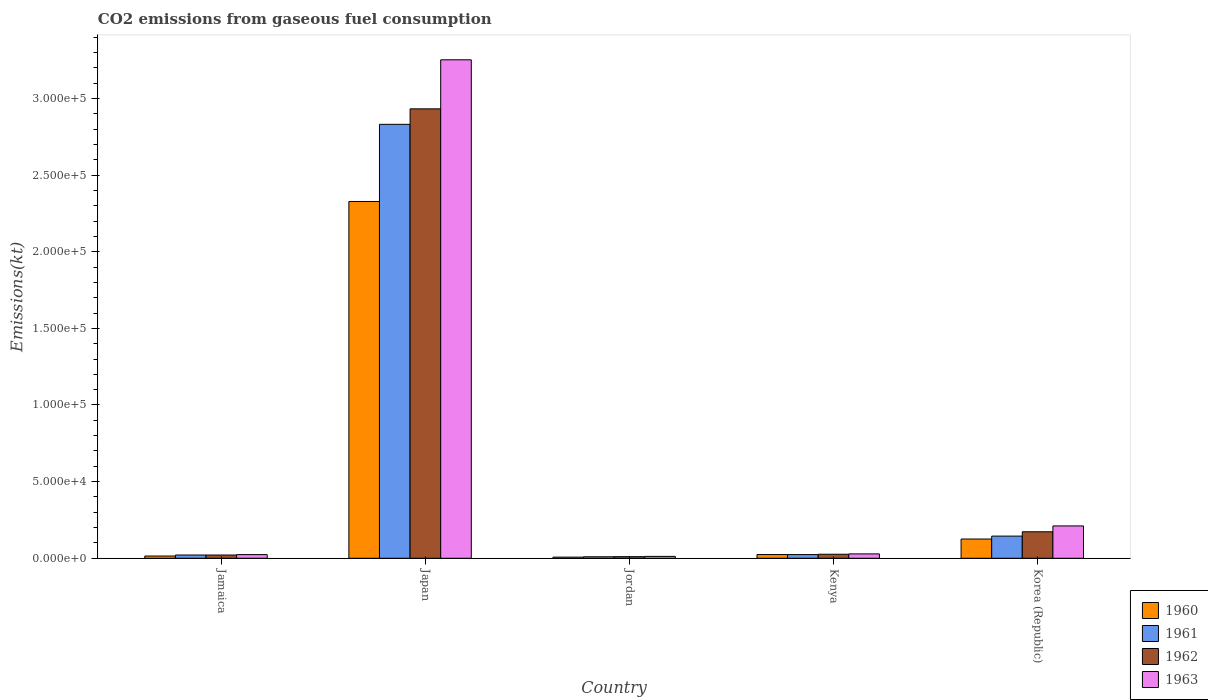Are the number of bars on each tick of the X-axis equal?
Your answer should be very brief. Yes. How many bars are there on the 5th tick from the left?
Give a very brief answer. 4. In how many cases, is the number of bars for a given country not equal to the number of legend labels?
Your response must be concise. 0. What is the amount of CO2 emitted in 1963 in Kenya?
Offer a very short reply. 2856.59. Across all countries, what is the maximum amount of CO2 emitted in 1963?
Provide a succinct answer. 3.25e+05. Across all countries, what is the minimum amount of CO2 emitted in 1963?
Your answer should be very brief. 1221.11. In which country was the amount of CO2 emitted in 1960 maximum?
Keep it short and to the point. Japan. In which country was the amount of CO2 emitted in 1963 minimum?
Your response must be concise. Jordan. What is the total amount of CO2 emitted in 1960 in the graph?
Offer a terse response. 2.50e+05. What is the difference between the amount of CO2 emitted in 1962 in Jamaica and that in Japan?
Offer a very short reply. -2.91e+05. What is the difference between the amount of CO2 emitted in 1961 in Jamaica and the amount of CO2 emitted in 1963 in Kenya?
Provide a succinct answer. -726.07. What is the average amount of CO2 emitted in 1962 per country?
Ensure brevity in your answer.  6.33e+04. What is the difference between the amount of CO2 emitted of/in 1961 and amount of CO2 emitted of/in 1962 in Jordan?
Make the answer very short. -69.67. What is the ratio of the amount of CO2 emitted in 1960 in Jamaica to that in Kenya?
Give a very brief answer. 0.61. Is the difference between the amount of CO2 emitted in 1961 in Jamaica and Jordan greater than the difference between the amount of CO2 emitted in 1962 in Jamaica and Jordan?
Give a very brief answer. Yes. What is the difference between the highest and the second highest amount of CO2 emitted in 1960?
Provide a short and direct response. 1.01e+04. What is the difference between the highest and the lowest amount of CO2 emitted in 1960?
Your response must be concise. 2.32e+05. In how many countries, is the amount of CO2 emitted in 1963 greater than the average amount of CO2 emitted in 1963 taken over all countries?
Your answer should be compact. 1. What does the 2nd bar from the left in Kenya represents?
Offer a very short reply. 1961. How many countries are there in the graph?
Give a very brief answer. 5. What is the difference between two consecutive major ticks on the Y-axis?
Offer a terse response. 5.00e+04. Are the values on the major ticks of Y-axis written in scientific E-notation?
Ensure brevity in your answer.  Yes. Does the graph contain any zero values?
Offer a very short reply. No. Does the graph contain grids?
Make the answer very short. No. How many legend labels are there?
Provide a short and direct response. 4. What is the title of the graph?
Your response must be concise. CO2 emissions from gaseous fuel consumption. What is the label or title of the X-axis?
Give a very brief answer. Country. What is the label or title of the Y-axis?
Make the answer very short. Emissions(kt). What is the Emissions(kt) of 1960 in Jamaica?
Ensure brevity in your answer.  1470.47. What is the Emissions(kt) in 1961 in Jamaica?
Your answer should be very brief. 2130.53. What is the Emissions(kt) in 1962 in Jamaica?
Your response must be concise. 2119.53. What is the Emissions(kt) in 1963 in Jamaica?
Keep it short and to the point. 2398.22. What is the Emissions(kt) in 1960 in Japan?
Your answer should be compact. 2.33e+05. What is the Emissions(kt) in 1961 in Japan?
Offer a very short reply. 2.83e+05. What is the Emissions(kt) of 1962 in Japan?
Your answer should be very brief. 2.93e+05. What is the Emissions(kt) of 1963 in Japan?
Offer a terse response. 3.25e+05. What is the Emissions(kt) of 1960 in Jordan?
Your answer should be compact. 744.4. What is the Emissions(kt) in 1961 in Jordan?
Make the answer very short. 979.09. What is the Emissions(kt) of 1962 in Jordan?
Offer a very short reply. 1048.76. What is the Emissions(kt) of 1963 in Jordan?
Provide a short and direct response. 1221.11. What is the Emissions(kt) of 1960 in Kenya?
Ensure brevity in your answer.  2427.55. What is the Emissions(kt) in 1961 in Kenya?
Ensure brevity in your answer.  2401.89. What is the Emissions(kt) of 1962 in Kenya?
Provide a short and direct response. 2625.57. What is the Emissions(kt) in 1963 in Kenya?
Provide a succinct answer. 2856.59. What is the Emissions(kt) of 1960 in Korea (Republic)?
Offer a very short reply. 1.26e+04. What is the Emissions(kt) of 1961 in Korea (Republic)?
Your answer should be compact. 1.45e+04. What is the Emissions(kt) in 1962 in Korea (Republic)?
Ensure brevity in your answer.  1.73e+04. What is the Emissions(kt) of 1963 in Korea (Republic)?
Keep it short and to the point. 2.11e+04. Across all countries, what is the maximum Emissions(kt) in 1960?
Offer a terse response. 2.33e+05. Across all countries, what is the maximum Emissions(kt) in 1961?
Make the answer very short. 2.83e+05. Across all countries, what is the maximum Emissions(kt) of 1962?
Offer a very short reply. 2.93e+05. Across all countries, what is the maximum Emissions(kt) of 1963?
Your answer should be compact. 3.25e+05. Across all countries, what is the minimum Emissions(kt) in 1960?
Provide a succinct answer. 744.4. Across all countries, what is the minimum Emissions(kt) of 1961?
Your answer should be compact. 979.09. Across all countries, what is the minimum Emissions(kt) in 1962?
Provide a short and direct response. 1048.76. Across all countries, what is the minimum Emissions(kt) in 1963?
Offer a terse response. 1221.11. What is the total Emissions(kt) in 1960 in the graph?
Make the answer very short. 2.50e+05. What is the total Emissions(kt) in 1961 in the graph?
Your response must be concise. 3.03e+05. What is the total Emissions(kt) in 1962 in the graph?
Offer a terse response. 3.16e+05. What is the total Emissions(kt) in 1963 in the graph?
Provide a short and direct response. 3.53e+05. What is the difference between the Emissions(kt) of 1960 in Jamaica and that in Japan?
Provide a succinct answer. -2.31e+05. What is the difference between the Emissions(kt) of 1961 in Jamaica and that in Japan?
Offer a terse response. -2.81e+05. What is the difference between the Emissions(kt) in 1962 in Jamaica and that in Japan?
Ensure brevity in your answer.  -2.91e+05. What is the difference between the Emissions(kt) in 1963 in Jamaica and that in Japan?
Offer a terse response. -3.23e+05. What is the difference between the Emissions(kt) of 1960 in Jamaica and that in Jordan?
Make the answer very short. 726.07. What is the difference between the Emissions(kt) in 1961 in Jamaica and that in Jordan?
Your answer should be compact. 1151.44. What is the difference between the Emissions(kt) in 1962 in Jamaica and that in Jordan?
Give a very brief answer. 1070.76. What is the difference between the Emissions(kt) of 1963 in Jamaica and that in Jordan?
Your answer should be compact. 1177.11. What is the difference between the Emissions(kt) in 1960 in Jamaica and that in Kenya?
Ensure brevity in your answer.  -957.09. What is the difference between the Emissions(kt) in 1961 in Jamaica and that in Kenya?
Provide a succinct answer. -271.36. What is the difference between the Emissions(kt) of 1962 in Jamaica and that in Kenya?
Your answer should be very brief. -506.05. What is the difference between the Emissions(kt) of 1963 in Jamaica and that in Kenya?
Provide a short and direct response. -458.38. What is the difference between the Emissions(kt) in 1960 in Jamaica and that in Korea (Republic)?
Your answer should be very brief. -1.11e+04. What is the difference between the Emissions(kt) of 1961 in Jamaica and that in Korea (Republic)?
Keep it short and to the point. -1.23e+04. What is the difference between the Emissions(kt) of 1962 in Jamaica and that in Korea (Republic)?
Provide a short and direct response. -1.52e+04. What is the difference between the Emissions(kt) of 1963 in Jamaica and that in Korea (Republic)?
Make the answer very short. -1.87e+04. What is the difference between the Emissions(kt) in 1960 in Japan and that in Jordan?
Offer a very short reply. 2.32e+05. What is the difference between the Emissions(kt) of 1961 in Japan and that in Jordan?
Your answer should be compact. 2.82e+05. What is the difference between the Emissions(kt) of 1962 in Japan and that in Jordan?
Keep it short and to the point. 2.92e+05. What is the difference between the Emissions(kt) of 1963 in Japan and that in Jordan?
Your response must be concise. 3.24e+05. What is the difference between the Emissions(kt) in 1960 in Japan and that in Kenya?
Provide a short and direct response. 2.30e+05. What is the difference between the Emissions(kt) in 1961 in Japan and that in Kenya?
Your answer should be compact. 2.81e+05. What is the difference between the Emissions(kt) in 1962 in Japan and that in Kenya?
Your response must be concise. 2.91e+05. What is the difference between the Emissions(kt) of 1963 in Japan and that in Kenya?
Offer a very short reply. 3.22e+05. What is the difference between the Emissions(kt) in 1960 in Japan and that in Korea (Republic)?
Your response must be concise. 2.20e+05. What is the difference between the Emissions(kt) of 1961 in Japan and that in Korea (Republic)?
Make the answer very short. 2.69e+05. What is the difference between the Emissions(kt) in 1962 in Japan and that in Korea (Republic)?
Make the answer very short. 2.76e+05. What is the difference between the Emissions(kt) of 1963 in Japan and that in Korea (Republic)?
Your answer should be compact. 3.04e+05. What is the difference between the Emissions(kt) in 1960 in Jordan and that in Kenya?
Give a very brief answer. -1683.15. What is the difference between the Emissions(kt) in 1961 in Jordan and that in Kenya?
Give a very brief answer. -1422.8. What is the difference between the Emissions(kt) of 1962 in Jordan and that in Kenya?
Provide a short and direct response. -1576.81. What is the difference between the Emissions(kt) of 1963 in Jordan and that in Kenya?
Your answer should be compact. -1635.48. What is the difference between the Emissions(kt) of 1960 in Jordan and that in Korea (Republic)?
Your answer should be very brief. -1.18e+04. What is the difference between the Emissions(kt) of 1961 in Jordan and that in Korea (Republic)?
Your answer should be very brief. -1.35e+04. What is the difference between the Emissions(kt) in 1962 in Jordan and that in Korea (Republic)?
Your response must be concise. -1.62e+04. What is the difference between the Emissions(kt) of 1963 in Jordan and that in Korea (Republic)?
Your response must be concise. -1.99e+04. What is the difference between the Emissions(kt) of 1960 in Kenya and that in Korea (Republic)?
Offer a terse response. -1.01e+04. What is the difference between the Emissions(kt) of 1961 in Kenya and that in Korea (Republic)?
Ensure brevity in your answer.  -1.21e+04. What is the difference between the Emissions(kt) of 1962 in Kenya and that in Korea (Republic)?
Ensure brevity in your answer.  -1.47e+04. What is the difference between the Emissions(kt) in 1963 in Kenya and that in Korea (Republic)?
Give a very brief answer. -1.82e+04. What is the difference between the Emissions(kt) in 1960 in Jamaica and the Emissions(kt) in 1961 in Japan?
Your answer should be very brief. -2.82e+05. What is the difference between the Emissions(kt) in 1960 in Jamaica and the Emissions(kt) in 1962 in Japan?
Your response must be concise. -2.92e+05. What is the difference between the Emissions(kt) in 1960 in Jamaica and the Emissions(kt) in 1963 in Japan?
Provide a succinct answer. -3.24e+05. What is the difference between the Emissions(kt) of 1961 in Jamaica and the Emissions(kt) of 1962 in Japan?
Provide a short and direct response. -2.91e+05. What is the difference between the Emissions(kt) of 1961 in Jamaica and the Emissions(kt) of 1963 in Japan?
Ensure brevity in your answer.  -3.23e+05. What is the difference between the Emissions(kt) in 1962 in Jamaica and the Emissions(kt) in 1963 in Japan?
Ensure brevity in your answer.  -3.23e+05. What is the difference between the Emissions(kt) in 1960 in Jamaica and the Emissions(kt) in 1961 in Jordan?
Make the answer very short. 491.38. What is the difference between the Emissions(kt) in 1960 in Jamaica and the Emissions(kt) in 1962 in Jordan?
Keep it short and to the point. 421.7. What is the difference between the Emissions(kt) in 1960 in Jamaica and the Emissions(kt) in 1963 in Jordan?
Offer a terse response. 249.36. What is the difference between the Emissions(kt) in 1961 in Jamaica and the Emissions(kt) in 1962 in Jordan?
Provide a succinct answer. 1081.77. What is the difference between the Emissions(kt) of 1961 in Jamaica and the Emissions(kt) of 1963 in Jordan?
Provide a short and direct response. 909.42. What is the difference between the Emissions(kt) in 1962 in Jamaica and the Emissions(kt) in 1963 in Jordan?
Keep it short and to the point. 898.41. What is the difference between the Emissions(kt) in 1960 in Jamaica and the Emissions(kt) in 1961 in Kenya?
Offer a very short reply. -931.42. What is the difference between the Emissions(kt) in 1960 in Jamaica and the Emissions(kt) in 1962 in Kenya?
Provide a short and direct response. -1155.11. What is the difference between the Emissions(kt) in 1960 in Jamaica and the Emissions(kt) in 1963 in Kenya?
Offer a very short reply. -1386.13. What is the difference between the Emissions(kt) in 1961 in Jamaica and the Emissions(kt) in 1962 in Kenya?
Your answer should be compact. -495.05. What is the difference between the Emissions(kt) of 1961 in Jamaica and the Emissions(kt) of 1963 in Kenya?
Your answer should be compact. -726.07. What is the difference between the Emissions(kt) of 1962 in Jamaica and the Emissions(kt) of 1963 in Kenya?
Your answer should be compact. -737.07. What is the difference between the Emissions(kt) of 1960 in Jamaica and the Emissions(kt) of 1961 in Korea (Republic)?
Provide a succinct answer. -1.30e+04. What is the difference between the Emissions(kt) in 1960 in Jamaica and the Emissions(kt) in 1962 in Korea (Republic)?
Offer a terse response. -1.58e+04. What is the difference between the Emissions(kt) in 1960 in Jamaica and the Emissions(kt) in 1963 in Korea (Republic)?
Make the answer very short. -1.96e+04. What is the difference between the Emissions(kt) of 1961 in Jamaica and the Emissions(kt) of 1962 in Korea (Republic)?
Give a very brief answer. -1.51e+04. What is the difference between the Emissions(kt) in 1961 in Jamaica and the Emissions(kt) in 1963 in Korea (Republic)?
Provide a short and direct response. -1.90e+04. What is the difference between the Emissions(kt) in 1962 in Jamaica and the Emissions(kt) in 1963 in Korea (Republic)?
Provide a succinct answer. -1.90e+04. What is the difference between the Emissions(kt) of 1960 in Japan and the Emissions(kt) of 1961 in Jordan?
Provide a succinct answer. 2.32e+05. What is the difference between the Emissions(kt) of 1960 in Japan and the Emissions(kt) of 1962 in Jordan?
Offer a terse response. 2.32e+05. What is the difference between the Emissions(kt) in 1960 in Japan and the Emissions(kt) in 1963 in Jordan?
Your response must be concise. 2.32e+05. What is the difference between the Emissions(kt) in 1961 in Japan and the Emissions(kt) in 1962 in Jordan?
Offer a very short reply. 2.82e+05. What is the difference between the Emissions(kt) of 1961 in Japan and the Emissions(kt) of 1963 in Jordan?
Make the answer very short. 2.82e+05. What is the difference between the Emissions(kt) in 1962 in Japan and the Emissions(kt) in 1963 in Jordan?
Offer a very short reply. 2.92e+05. What is the difference between the Emissions(kt) in 1960 in Japan and the Emissions(kt) in 1961 in Kenya?
Ensure brevity in your answer.  2.30e+05. What is the difference between the Emissions(kt) in 1960 in Japan and the Emissions(kt) in 1962 in Kenya?
Your answer should be very brief. 2.30e+05. What is the difference between the Emissions(kt) of 1960 in Japan and the Emissions(kt) of 1963 in Kenya?
Your response must be concise. 2.30e+05. What is the difference between the Emissions(kt) of 1961 in Japan and the Emissions(kt) of 1962 in Kenya?
Provide a succinct answer. 2.80e+05. What is the difference between the Emissions(kt) of 1961 in Japan and the Emissions(kt) of 1963 in Kenya?
Offer a terse response. 2.80e+05. What is the difference between the Emissions(kt) of 1962 in Japan and the Emissions(kt) of 1963 in Kenya?
Provide a short and direct response. 2.90e+05. What is the difference between the Emissions(kt) of 1960 in Japan and the Emissions(kt) of 1961 in Korea (Republic)?
Your response must be concise. 2.18e+05. What is the difference between the Emissions(kt) of 1960 in Japan and the Emissions(kt) of 1962 in Korea (Republic)?
Offer a terse response. 2.16e+05. What is the difference between the Emissions(kt) in 1960 in Japan and the Emissions(kt) in 1963 in Korea (Republic)?
Your answer should be very brief. 2.12e+05. What is the difference between the Emissions(kt) of 1961 in Japan and the Emissions(kt) of 1962 in Korea (Republic)?
Provide a short and direct response. 2.66e+05. What is the difference between the Emissions(kt) of 1961 in Japan and the Emissions(kt) of 1963 in Korea (Republic)?
Give a very brief answer. 2.62e+05. What is the difference between the Emissions(kt) in 1962 in Japan and the Emissions(kt) in 1963 in Korea (Republic)?
Make the answer very short. 2.72e+05. What is the difference between the Emissions(kt) in 1960 in Jordan and the Emissions(kt) in 1961 in Kenya?
Make the answer very short. -1657.48. What is the difference between the Emissions(kt) of 1960 in Jordan and the Emissions(kt) of 1962 in Kenya?
Provide a succinct answer. -1881.17. What is the difference between the Emissions(kt) of 1960 in Jordan and the Emissions(kt) of 1963 in Kenya?
Your response must be concise. -2112.19. What is the difference between the Emissions(kt) of 1961 in Jordan and the Emissions(kt) of 1962 in Kenya?
Your response must be concise. -1646.48. What is the difference between the Emissions(kt) of 1961 in Jordan and the Emissions(kt) of 1963 in Kenya?
Provide a short and direct response. -1877.5. What is the difference between the Emissions(kt) in 1962 in Jordan and the Emissions(kt) in 1963 in Kenya?
Keep it short and to the point. -1807.83. What is the difference between the Emissions(kt) in 1960 in Jordan and the Emissions(kt) in 1961 in Korea (Republic)?
Give a very brief answer. -1.37e+04. What is the difference between the Emissions(kt) in 1960 in Jordan and the Emissions(kt) in 1962 in Korea (Republic)?
Your response must be concise. -1.65e+04. What is the difference between the Emissions(kt) of 1960 in Jordan and the Emissions(kt) of 1963 in Korea (Republic)?
Give a very brief answer. -2.04e+04. What is the difference between the Emissions(kt) in 1961 in Jordan and the Emissions(kt) in 1962 in Korea (Republic)?
Make the answer very short. -1.63e+04. What is the difference between the Emissions(kt) in 1961 in Jordan and the Emissions(kt) in 1963 in Korea (Republic)?
Make the answer very short. -2.01e+04. What is the difference between the Emissions(kt) of 1962 in Jordan and the Emissions(kt) of 1963 in Korea (Republic)?
Your response must be concise. -2.01e+04. What is the difference between the Emissions(kt) of 1960 in Kenya and the Emissions(kt) of 1961 in Korea (Republic)?
Ensure brevity in your answer.  -1.20e+04. What is the difference between the Emissions(kt) of 1960 in Kenya and the Emissions(kt) of 1962 in Korea (Republic)?
Your answer should be very brief. -1.49e+04. What is the difference between the Emissions(kt) of 1960 in Kenya and the Emissions(kt) of 1963 in Korea (Republic)?
Keep it short and to the point. -1.87e+04. What is the difference between the Emissions(kt) in 1961 in Kenya and the Emissions(kt) in 1962 in Korea (Republic)?
Offer a terse response. -1.49e+04. What is the difference between the Emissions(kt) of 1961 in Kenya and the Emissions(kt) of 1963 in Korea (Republic)?
Your response must be concise. -1.87e+04. What is the difference between the Emissions(kt) of 1962 in Kenya and the Emissions(kt) of 1963 in Korea (Republic)?
Keep it short and to the point. -1.85e+04. What is the average Emissions(kt) of 1960 per country?
Your response must be concise. 5.00e+04. What is the average Emissions(kt) in 1961 per country?
Make the answer very short. 6.06e+04. What is the average Emissions(kt) of 1962 per country?
Make the answer very short. 6.33e+04. What is the average Emissions(kt) of 1963 per country?
Your answer should be compact. 7.06e+04. What is the difference between the Emissions(kt) of 1960 and Emissions(kt) of 1961 in Jamaica?
Keep it short and to the point. -660.06. What is the difference between the Emissions(kt) of 1960 and Emissions(kt) of 1962 in Jamaica?
Provide a succinct answer. -649.06. What is the difference between the Emissions(kt) in 1960 and Emissions(kt) in 1963 in Jamaica?
Provide a short and direct response. -927.75. What is the difference between the Emissions(kt) of 1961 and Emissions(kt) of 1962 in Jamaica?
Offer a terse response. 11. What is the difference between the Emissions(kt) of 1961 and Emissions(kt) of 1963 in Jamaica?
Offer a terse response. -267.69. What is the difference between the Emissions(kt) of 1962 and Emissions(kt) of 1963 in Jamaica?
Offer a terse response. -278.69. What is the difference between the Emissions(kt) in 1960 and Emissions(kt) in 1961 in Japan?
Offer a very short reply. -5.03e+04. What is the difference between the Emissions(kt) in 1960 and Emissions(kt) in 1962 in Japan?
Offer a very short reply. -6.04e+04. What is the difference between the Emissions(kt) in 1960 and Emissions(kt) in 1963 in Japan?
Your answer should be compact. -9.24e+04. What is the difference between the Emissions(kt) of 1961 and Emissions(kt) of 1962 in Japan?
Provide a short and direct response. -1.01e+04. What is the difference between the Emissions(kt) of 1961 and Emissions(kt) of 1963 in Japan?
Ensure brevity in your answer.  -4.21e+04. What is the difference between the Emissions(kt) in 1962 and Emissions(kt) in 1963 in Japan?
Offer a terse response. -3.20e+04. What is the difference between the Emissions(kt) in 1960 and Emissions(kt) in 1961 in Jordan?
Your answer should be very brief. -234.69. What is the difference between the Emissions(kt) in 1960 and Emissions(kt) in 1962 in Jordan?
Your answer should be very brief. -304.36. What is the difference between the Emissions(kt) of 1960 and Emissions(kt) of 1963 in Jordan?
Make the answer very short. -476.71. What is the difference between the Emissions(kt) of 1961 and Emissions(kt) of 1962 in Jordan?
Make the answer very short. -69.67. What is the difference between the Emissions(kt) of 1961 and Emissions(kt) of 1963 in Jordan?
Provide a short and direct response. -242.02. What is the difference between the Emissions(kt) in 1962 and Emissions(kt) in 1963 in Jordan?
Provide a short and direct response. -172.35. What is the difference between the Emissions(kt) in 1960 and Emissions(kt) in 1961 in Kenya?
Provide a succinct answer. 25.67. What is the difference between the Emissions(kt) in 1960 and Emissions(kt) in 1962 in Kenya?
Provide a succinct answer. -198.02. What is the difference between the Emissions(kt) of 1960 and Emissions(kt) of 1963 in Kenya?
Keep it short and to the point. -429.04. What is the difference between the Emissions(kt) in 1961 and Emissions(kt) in 1962 in Kenya?
Give a very brief answer. -223.69. What is the difference between the Emissions(kt) of 1961 and Emissions(kt) of 1963 in Kenya?
Keep it short and to the point. -454.71. What is the difference between the Emissions(kt) in 1962 and Emissions(kt) in 1963 in Kenya?
Give a very brief answer. -231.02. What is the difference between the Emissions(kt) in 1960 and Emissions(kt) in 1961 in Korea (Republic)?
Keep it short and to the point. -1910.51. What is the difference between the Emissions(kt) of 1960 and Emissions(kt) of 1962 in Korea (Republic)?
Give a very brief answer. -4726.76. What is the difference between the Emissions(kt) in 1960 and Emissions(kt) in 1963 in Korea (Republic)?
Make the answer very short. -8551.44. What is the difference between the Emissions(kt) of 1961 and Emissions(kt) of 1962 in Korea (Republic)?
Your answer should be very brief. -2816.26. What is the difference between the Emissions(kt) in 1961 and Emissions(kt) in 1963 in Korea (Republic)?
Provide a short and direct response. -6640.94. What is the difference between the Emissions(kt) in 1962 and Emissions(kt) in 1963 in Korea (Republic)?
Offer a terse response. -3824.68. What is the ratio of the Emissions(kt) of 1960 in Jamaica to that in Japan?
Keep it short and to the point. 0.01. What is the ratio of the Emissions(kt) in 1961 in Jamaica to that in Japan?
Provide a succinct answer. 0.01. What is the ratio of the Emissions(kt) in 1962 in Jamaica to that in Japan?
Make the answer very short. 0.01. What is the ratio of the Emissions(kt) of 1963 in Jamaica to that in Japan?
Provide a succinct answer. 0.01. What is the ratio of the Emissions(kt) in 1960 in Jamaica to that in Jordan?
Ensure brevity in your answer.  1.98. What is the ratio of the Emissions(kt) in 1961 in Jamaica to that in Jordan?
Offer a very short reply. 2.18. What is the ratio of the Emissions(kt) in 1962 in Jamaica to that in Jordan?
Offer a terse response. 2.02. What is the ratio of the Emissions(kt) in 1963 in Jamaica to that in Jordan?
Offer a very short reply. 1.96. What is the ratio of the Emissions(kt) of 1960 in Jamaica to that in Kenya?
Keep it short and to the point. 0.61. What is the ratio of the Emissions(kt) in 1961 in Jamaica to that in Kenya?
Offer a very short reply. 0.89. What is the ratio of the Emissions(kt) of 1962 in Jamaica to that in Kenya?
Your answer should be compact. 0.81. What is the ratio of the Emissions(kt) in 1963 in Jamaica to that in Kenya?
Ensure brevity in your answer.  0.84. What is the ratio of the Emissions(kt) of 1960 in Jamaica to that in Korea (Republic)?
Ensure brevity in your answer.  0.12. What is the ratio of the Emissions(kt) of 1961 in Jamaica to that in Korea (Republic)?
Your answer should be very brief. 0.15. What is the ratio of the Emissions(kt) in 1962 in Jamaica to that in Korea (Republic)?
Your answer should be compact. 0.12. What is the ratio of the Emissions(kt) in 1963 in Jamaica to that in Korea (Republic)?
Offer a terse response. 0.11. What is the ratio of the Emissions(kt) of 1960 in Japan to that in Jordan?
Give a very brief answer. 312.71. What is the ratio of the Emissions(kt) in 1961 in Japan to that in Jordan?
Offer a very short reply. 289.16. What is the ratio of the Emissions(kt) of 1962 in Japan to that in Jordan?
Your answer should be compact. 279.59. What is the ratio of the Emissions(kt) of 1963 in Japan to that in Jordan?
Ensure brevity in your answer.  266.33. What is the ratio of the Emissions(kt) in 1960 in Japan to that in Kenya?
Your answer should be compact. 95.89. What is the ratio of the Emissions(kt) of 1961 in Japan to that in Kenya?
Your response must be concise. 117.87. What is the ratio of the Emissions(kt) in 1962 in Japan to that in Kenya?
Ensure brevity in your answer.  111.68. What is the ratio of the Emissions(kt) in 1963 in Japan to that in Kenya?
Make the answer very short. 113.85. What is the ratio of the Emissions(kt) in 1960 in Japan to that in Korea (Republic)?
Ensure brevity in your answer.  18.55. What is the ratio of the Emissions(kt) of 1961 in Japan to that in Korea (Republic)?
Keep it short and to the point. 19.58. What is the ratio of the Emissions(kt) of 1962 in Japan to that in Korea (Republic)?
Ensure brevity in your answer.  16.97. What is the ratio of the Emissions(kt) of 1963 in Japan to that in Korea (Republic)?
Offer a terse response. 15.41. What is the ratio of the Emissions(kt) in 1960 in Jordan to that in Kenya?
Ensure brevity in your answer.  0.31. What is the ratio of the Emissions(kt) of 1961 in Jordan to that in Kenya?
Give a very brief answer. 0.41. What is the ratio of the Emissions(kt) of 1962 in Jordan to that in Kenya?
Offer a very short reply. 0.4. What is the ratio of the Emissions(kt) in 1963 in Jordan to that in Kenya?
Offer a terse response. 0.43. What is the ratio of the Emissions(kt) in 1960 in Jordan to that in Korea (Republic)?
Offer a very short reply. 0.06. What is the ratio of the Emissions(kt) of 1961 in Jordan to that in Korea (Republic)?
Ensure brevity in your answer.  0.07. What is the ratio of the Emissions(kt) of 1962 in Jordan to that in Korea (Republic)?
Your answer should be very brief. 0.06. What is the ratio of the Emissions(kt) in 1963 in Jordan to that in Korea (Republic)?
Provide a short and direct response. 0.06. What is the ratio of the Emissions(kt) in 1960 in Kenya to that in Korea (Republic)?
Provide a short and direct response. 0.19. What is the ratio of the Emissions(kt) in 1961 in Kenya to that in Korea (Republic)?
Ensure brevity in your answer.  0.17. What is the ratio of the Emissions(kt) of 1962 in Kenya to that in Korea (Republic)?
Provide a short and direct response. 0.15. What is the ratio of the Emissions(kt) in 1963 in Kenya to that in Korea (Republic)?
Your response must be concise. 0.14. What is the difference between the highest and the second highest Emissions(kt) of 1960?
Keep it short and to the point. 2.20e+05. What is the difference between the highest and the second highest Emissions(kt) of 1961?
Provide a short and direct response. 2.69e+05. What is the difference between the highest and the second highest Emissions(kt) of 1962?
Offer a very short reply. 2.76e+05. What is the difference between the highest and the second highest Emissions(kt) of 1963?
Your response must be concise. 3.04e+05. What is the difference between the highest and the lowest Emissions(kt) in 1960?
Your response must be concise. 2.32e+05. What is the difference between the highest and the lowest Emissions(kt) of 1961?
Give a very brief answer. 2.82e+05. What is the difference between the highest and the lowest Emissions(kt) of 1962?
Ensure brevity in your answer.  2.92e+05. What is the difference between the highest and the lowest Emissions(kt) in 1963?
Offer a terse response. 3.24e+05. 